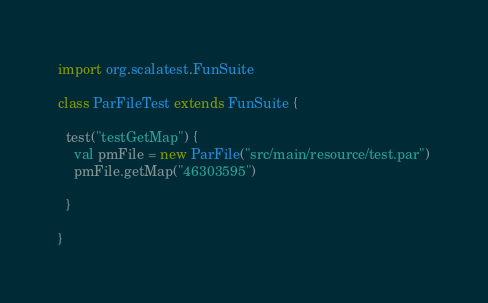Convert code to text. <code><loc_0><loc_0><loc_500><loc_500><_Scala_>import org.scalatest.FunSuite

class ParFileTest extends FunSuite {

  test("testGetMap") {
    val pmFile = new ParFile("src/main/resource/test.par")
    pmFile.getMap("46303595")

  }

}
</code> 